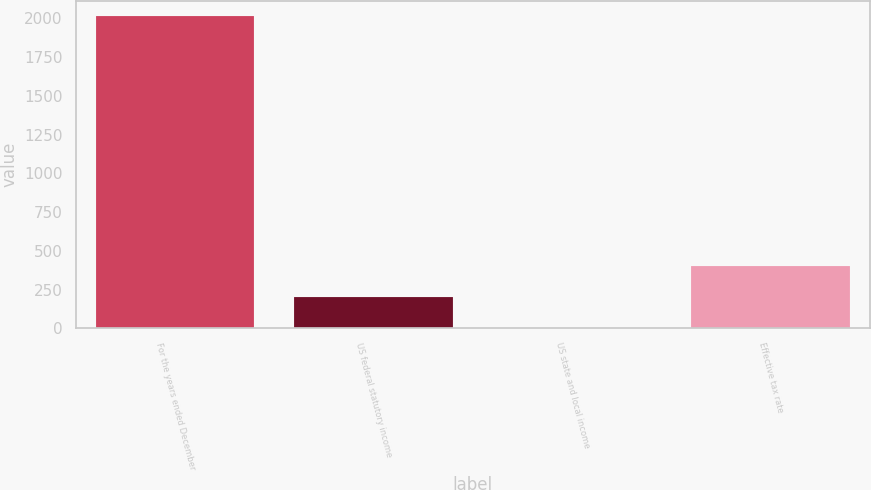Convert chart to OTSL. <chart><loc_0><loc_0><loc_500><loc_500><bar_chart><fcel>For the years ended December<fcel>US federal statutory income<fcel>US state and local income<fcel>Effective tax rate<nl><fcel>2013<fcel>203.01<fcel>1.9<fcel>404.12<nl></chart> 